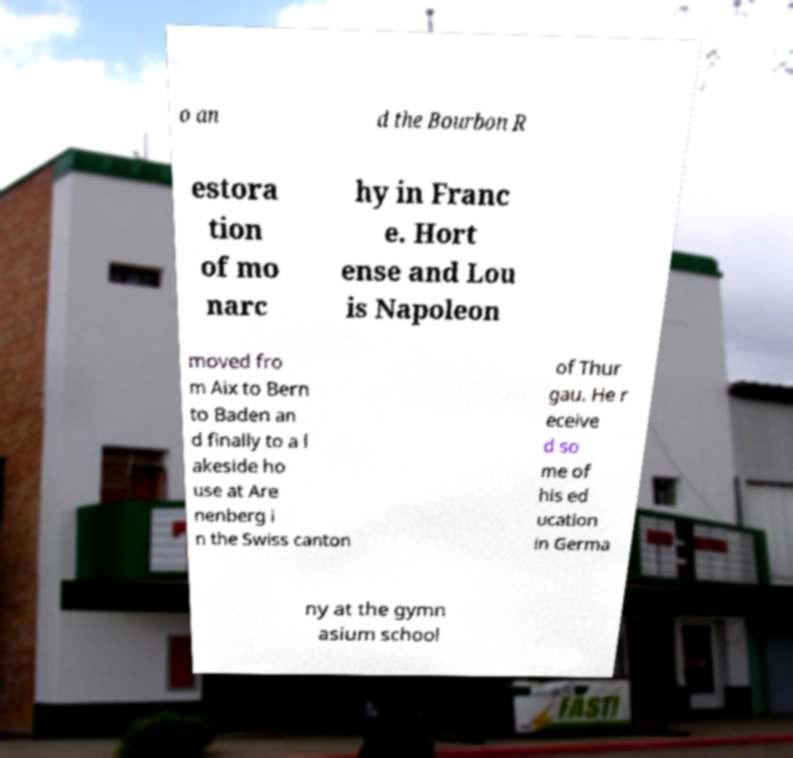Could you extract and type out the text from this image? o an d the Bourbon R estora tion of mo narc hy in Franc e. Hort ense and Lou is Napoleon moved fro m Aix to Bern to Baden an d finally to a l akeside ho use at Are nenberg i n the Swiss canton of Thur gau. He r eceive d so me of his ed ucation in Germa ny at the gymn asium school 